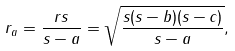Convert formula to latex. <formula><loc_0><loc_0><loc_500><loc_500>r _ { a } = { \frac { r s } { s - a } } = { \sqrt { \frac { s ( s - b ) ( s - c ) } { s - a } } } ,</formula> 